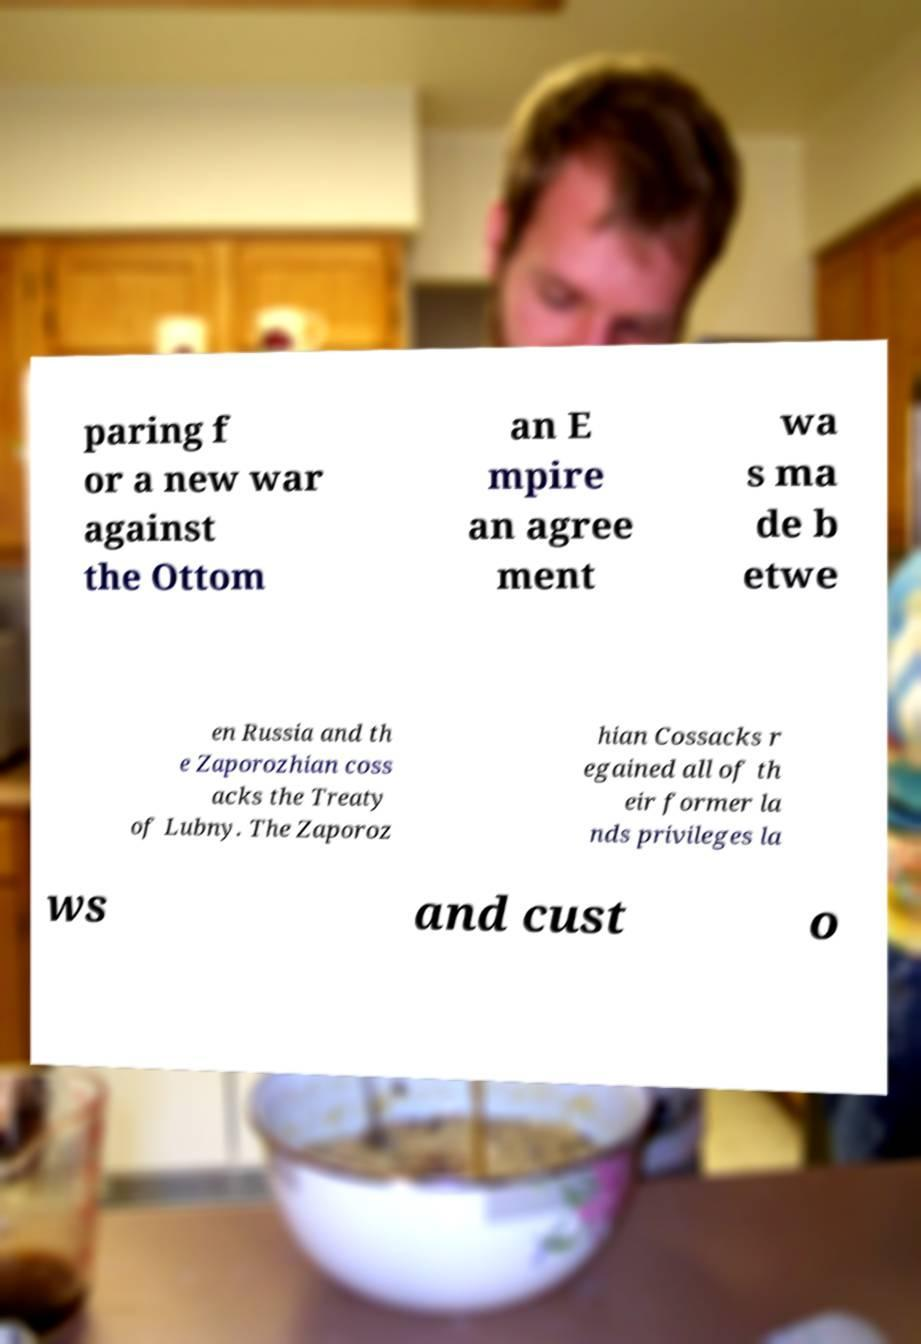Please read and relay the text visible in this image. What does it say? paring f or a new war against the Ottom an E mpire an agree ment wa s ma de b etwe en Russia and th e Zaporozhian coss acks the Treaty of Lubny. The Zaporoz hian Cossacks r egained all of th eir former la nds privileges la ws and cust o 